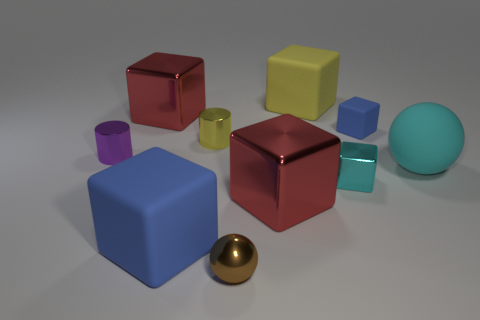Subtract all cyan blocks. How many blocks are left? 5 Subtract 2 balls. How many balls are left? 0 Subtract all blue blocks. How many blocks are left? 4 Subtract all small yellow objects. Subtract all red objects. How many objects are left? 7 Add 7 big cyan objects. How many big cyan objects are left? 8 Add 10 tiny purple matte spheres. How many tiny purple matte spheres exist? 10 Subtract 2 red blocks. How many objects are left? 8 Subtract all spheres. How many objects are left? 8 Subtract all gray balls. Subtract all green blocks. How many balls are left? 2 Subtract all gray balls. How many cyan blocks are left? 1 